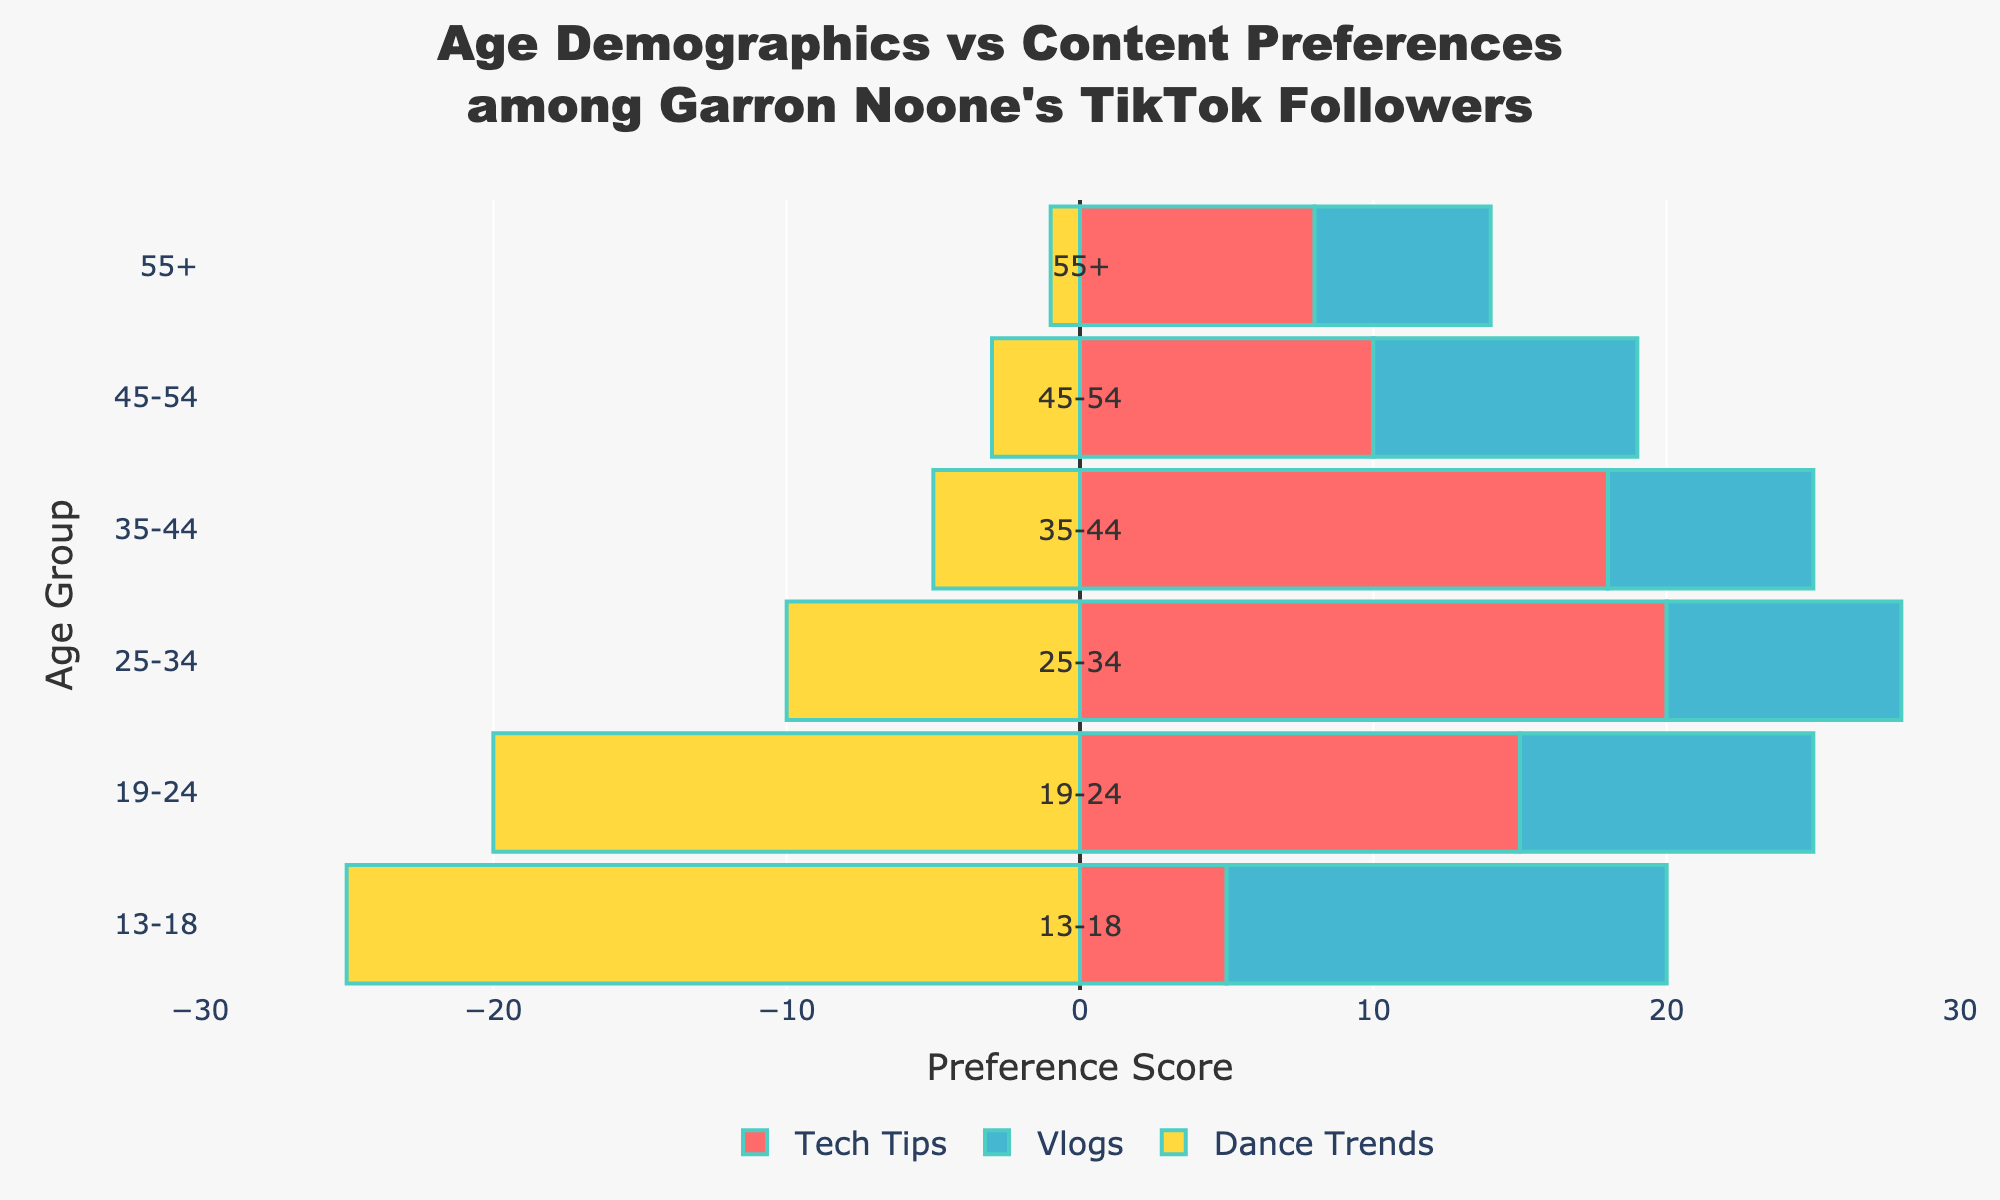How do the content preferences of the age group 13-18 compare with those of the age group 35-44? For the age group 13-18, the preferences are 5 for Tech Tips, 15 for Vlogs, and 25 for Dance Trends. For the age group 35-44, the preferences are 18 for Tech Tips, 7 for Vlogs, and 5 for Dance Trends. Comparing these, the 13-18 group prefers Dance Trends significantly more than the 35-44 group, while the 35-44 group prefers Tech Tips much more than the 13-18 group. Both groups have a moderate interest in Vlogs, though the 13-18 group shows a higher preference.
Answer: The 13-18 group prefers Dance Trends, the 35-44 group prefers Tech Tips Which age group shows the highest preference for Tech Tips, and what is that preference score? Looking at the red bars representing Tech Tips, the longest bar corresponds to the age group 25-34. This age group has a preference score of 20 for Tech Tips.
Answer: 25-34, 20 What is the difference in the preference score for Vlogs between the age groups 19-24 and 45-54? The 19-24 age group has a preference score of 10 for Vlogs, while the 45-54 age group has a score of 9 for Vlogs. The difference is calculated as 10 - 9.
Answer: 1 Comparing the age groups 25-34 and 55+, which group has a higher preference for Dance Trends, and by how much? The preference score for Dance Trends in the 25-34 age group is 10 while it is 1 for the 55+ age group. The difference is 10 - 1.
Answer: 25-34, 9 What is the average preference score for Dance Trends across all age groups? The preference scores for Dance Trends across all age groups are 25, 20, 10, 5, 3, and 1. Summing these values gives 64. Dividing by the number of age groups (6) gives the average as 64 / 6.
Answer: 10.67 By looking at the visual attributes, which content type has the most noticeable divergence in preferences across age groups? Dance Trends have bars stretching to the left (negative values) and display substantial variations across age groups, clearly showing a notable divergence. The colors and lengths visually stand out.
Answer: Dance Trends What is the total preference score for Vlogs across all age groups? The preference scores for Vlogs are 15, 10, 8, 7, 9, and 6. Adding these values gives the total: 15 + 10 + 8 + 7 + 9 + 6.
Answer: 55 For the age group 13-18, what is the combined preference score for Tech Tips and Dance Trends? The preference score for Tech Tips is 5, and for Dance Trends, it is 25. Adding these together gives 5 + 25.
Answer: 30 